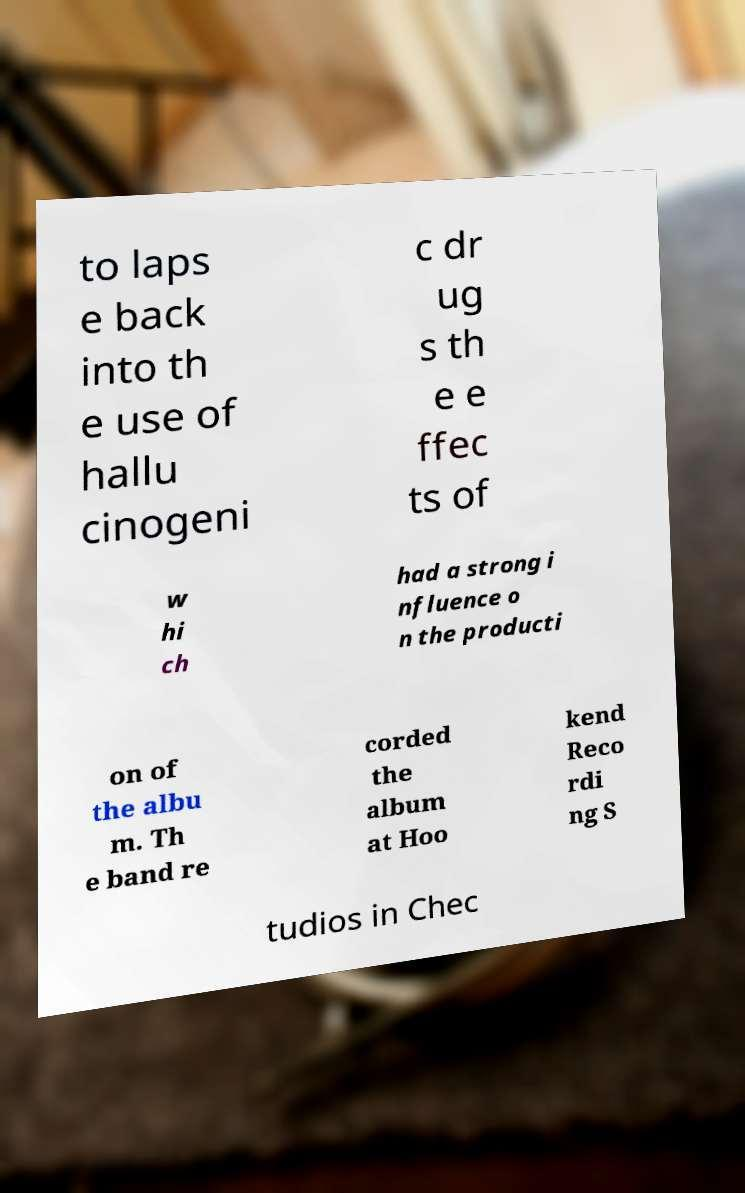What messages or text are displayed in this image? I need them in a readable, typed format. to laps e back into th e use of hallu cinogeni c dr ug s th e e ffec ts of w hi ch had a strong i nfluence o n the producti on of the albu m. Th e band re corded the album at Hoo kend Reco rdi ng S tudios in Chec 